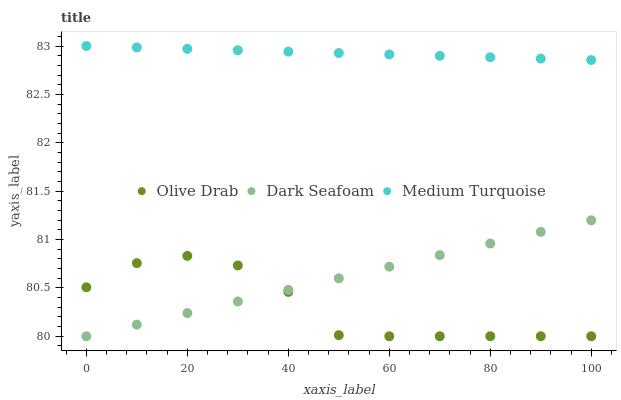Does Olive Drab have the minimum area under the curve?
Answer yes or no. Yes. Does Medium Turquoise have the maximum area under the curve?
Answer yes or no. Yes. Does Medium Turquoise have the minimum area under the curve?
Answer yes or no. No. Does Olive Drab have the maximum area under the curve?
Answer yes or no. No. Is Dark Seafoam the smoothest?
Answer yes or no. Yes. Is Olive Drab the roughest?
Answer yes or no. Yes. Is Medium Turquoise the smoothest?
Answer yes or no. No. Is Medium Turquoise the roughest?
Answer yes or no. No. Does Dark Seafoam have the lowest value?
Answer yes or no. Yes. Does Medium Turquoise have the lowest value?
Answer yes or no. No. Does Medium Turquoise have the highest value?
Answer yes or no. Yes. Does Olive Drab have the highest value?
Answer yes or no. No. Is Dark Seafoam less than Medium Turquoise?
Answer yes or no. Yes. Is Medium Turquoise greater than Dark Seafoam?
Answer yes or no. Yes. Does Dark Seafoam intersect Olive Drab?
Answer yes or no. Yes. Is Dark Seafoam less than Olive Drab?
Answer yes or no. No. Is Dark Seafoam greater than Olive Drab?
Answer yes or no. No. Does Dark Seafoam intersect Medium Turquoise?
Answer yes or no. No. 